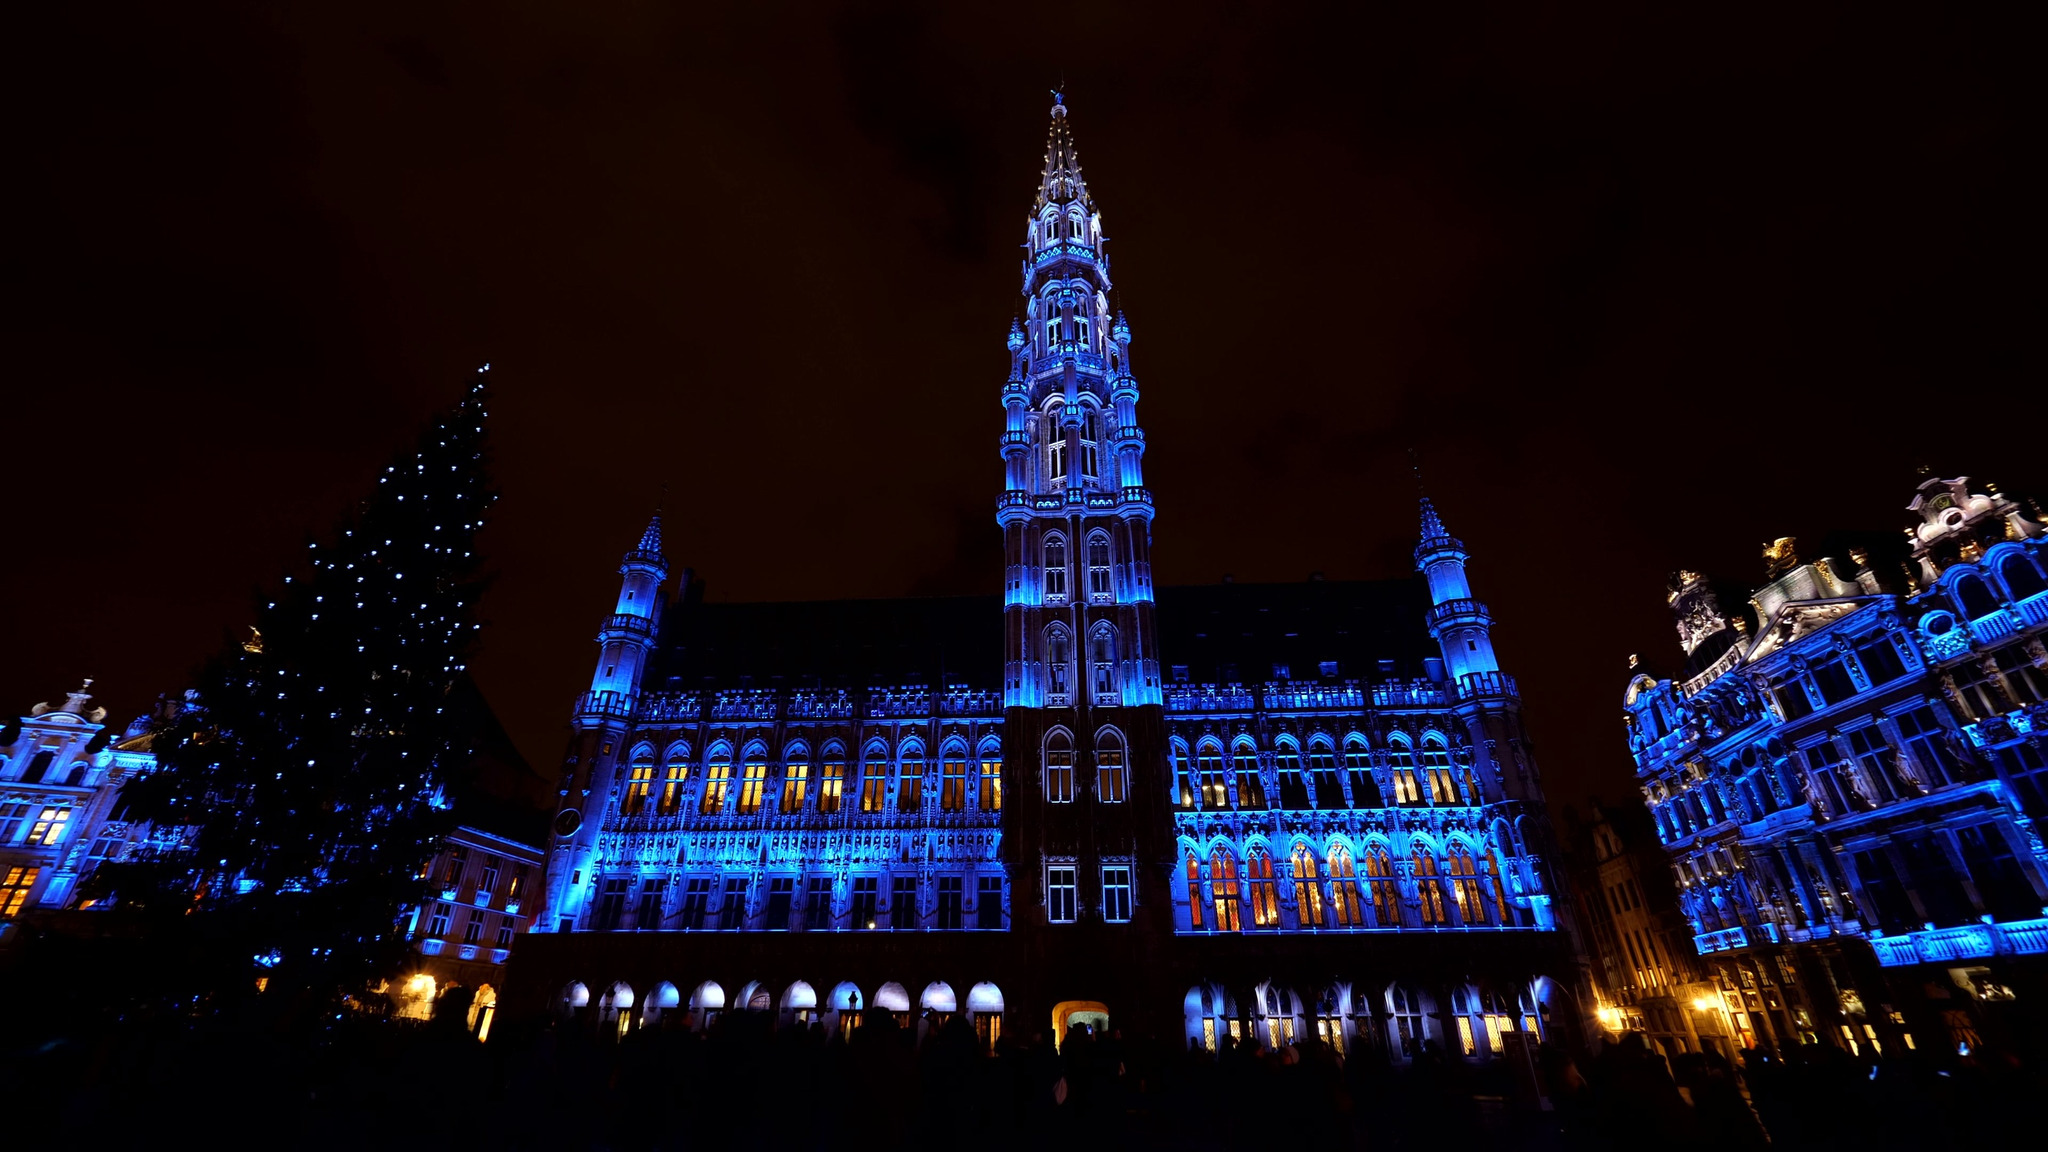Imagine if the Brussels Town Hall could talk. What stories might it share? If the Brussels Town Hall could speak, it would regale listeners with centuries of stories, from medieval times to the modern era. It would recount the day it was completed and the grand celebrations that took place, the fluttering banners, and the bustling crowd. It might share tales of the many rulers it has seen, from Dukes to mayors, each leaving their mark on its walls. Perhaps it would tell us about the dark days of invasion and war, standing resilient through cannon fire and bombs. The Town Hall could speak of countless weddings, civic ceremonies, and jubilant festivals that brought life and laughter to its halls. It would also have tales of artists and architects who painstakingly restored its grandeur after damage, ensuring its beauty was preserved for future generations. Each of its stones holds a story, each window a glimpse into a colorful past full of grandeur, resilience, and celebration. What might be a fictional tale that includes the Brussels Town Hall as a central element? In a fantastical tale, the Brussels Town Hall might be the guardian of an ancient relic with mysterious powers. Set in medieval times, a young orphan named Elara discovers a hidden chamber within the Town Hall that contains a map leading to the relic. With the help of her friends—a brave knight, a reclusive scholar, and a street-smart thief—she embarks on an epic quest across kingdoms. The journey is filled with enchanted forests, mythical creatures, and treacherous villains who seek the relic for their own sinister purposes. Throughout her adventure, Elara learns about her past and the true power of the relic. The climax of the story sees a massive battle in the Grand Place, with the Town Hall’s hidden defenses coming to life to protect the city from invaders. In the end, Elara uses the relic’s power not for grandeur but to restore peace and prosperity to the land, becoming a beloved hero whose tale is etched into the Town Hall’s very stones. Is the Brussels Town Hall significant in any legends or myths? While not widely known for any specific myths, the Brussels Town Hall certainly inspires its own share of legends. One such legend speaks of a secret underground tunnel connecting the Town Hall to other significant buildings in the city, used by ancient rulers to escape during sieges. Another tale often told by locals is of a ghostly figure—the spirit of an architect distraught over the unaligned spire—wandering the hallways, forever seeking to perfect his masterpiece. These stories, whether fact or fiction, add to the enigmatic allure of the Town Hall, making it a focal point of cultural and historical fascination in Brussels. What significance does the Brussels Town Hall hold in modern-day Brussels? In modern-day Brussels, the Town Hall holds substantial cultural, historical, and administrative significance. It continues to function as the seat of local government, hosting official delegations, city council meetings, and state functions. Architectural enthusiasts revere it for its meticulously preserved Gothic design, and it remains a key tourist attraction, drawing visitors from around the globe. The Grand Place, with the Town Hall as its centerpiece, serves as a vibrant social and cultural gathering spot for festivals, concerts, and public celebrations, creating a sense of community and continuity between Brussels’ rich heritage and its dynamic present. 